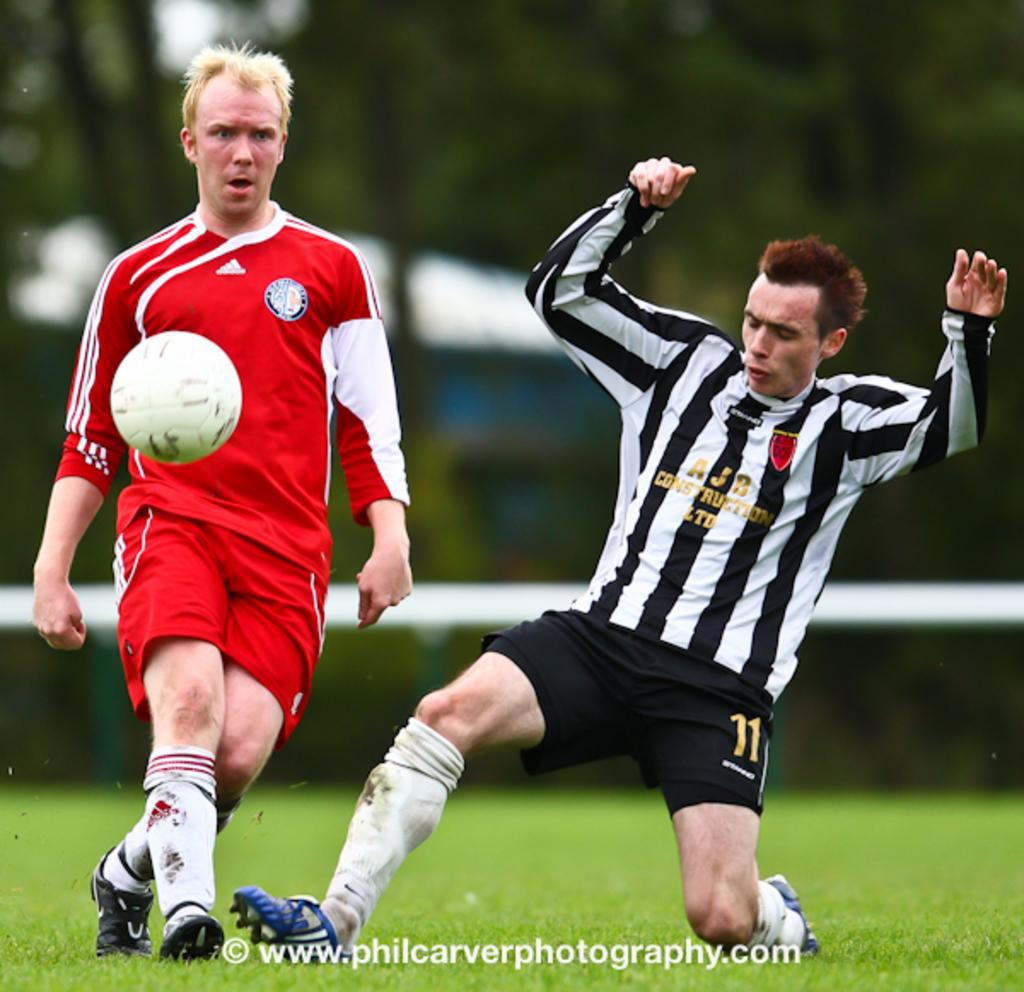<image>
Write a terse but informative summary of the picture. AJB Construction LTD, number 11 is shown on this player's uniform. 